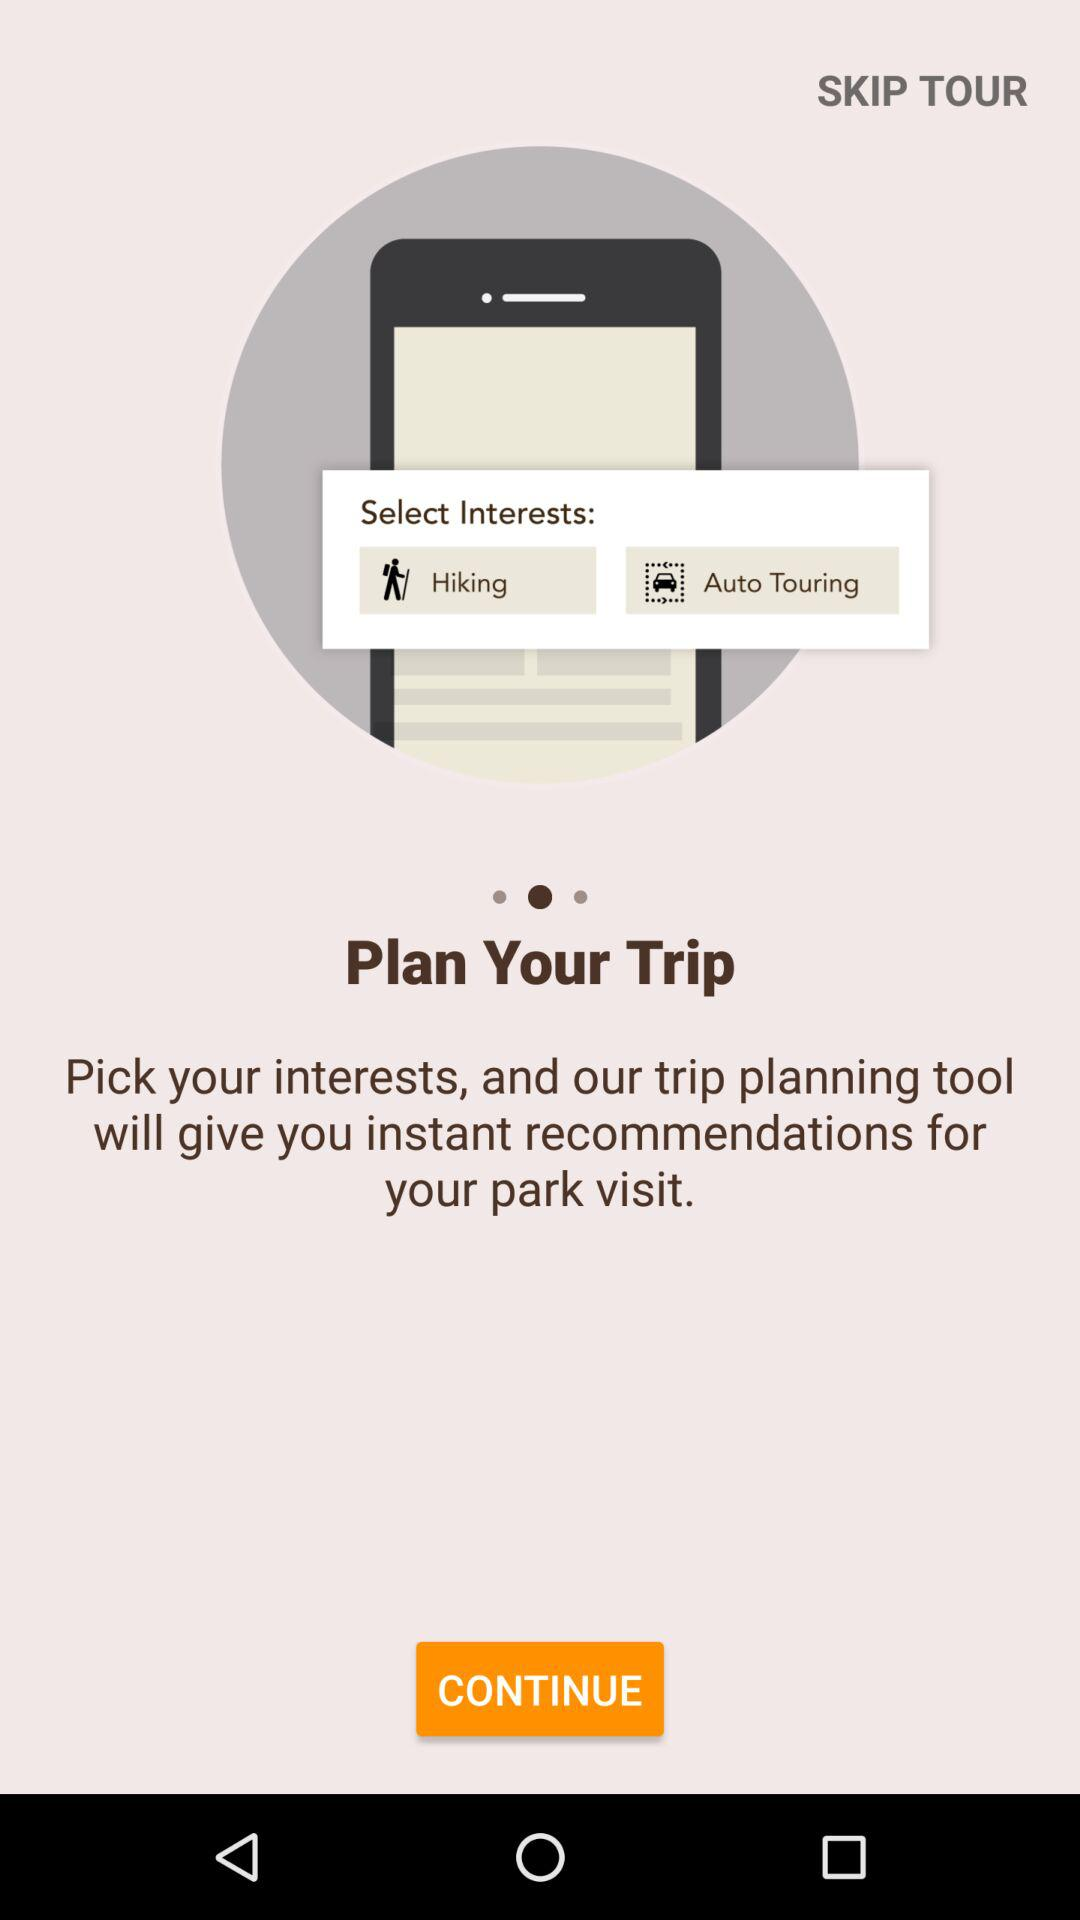What will the trip planning tool do by picking interests? By picking interests, our planning tool will give you instant recommendations for your park visit. 